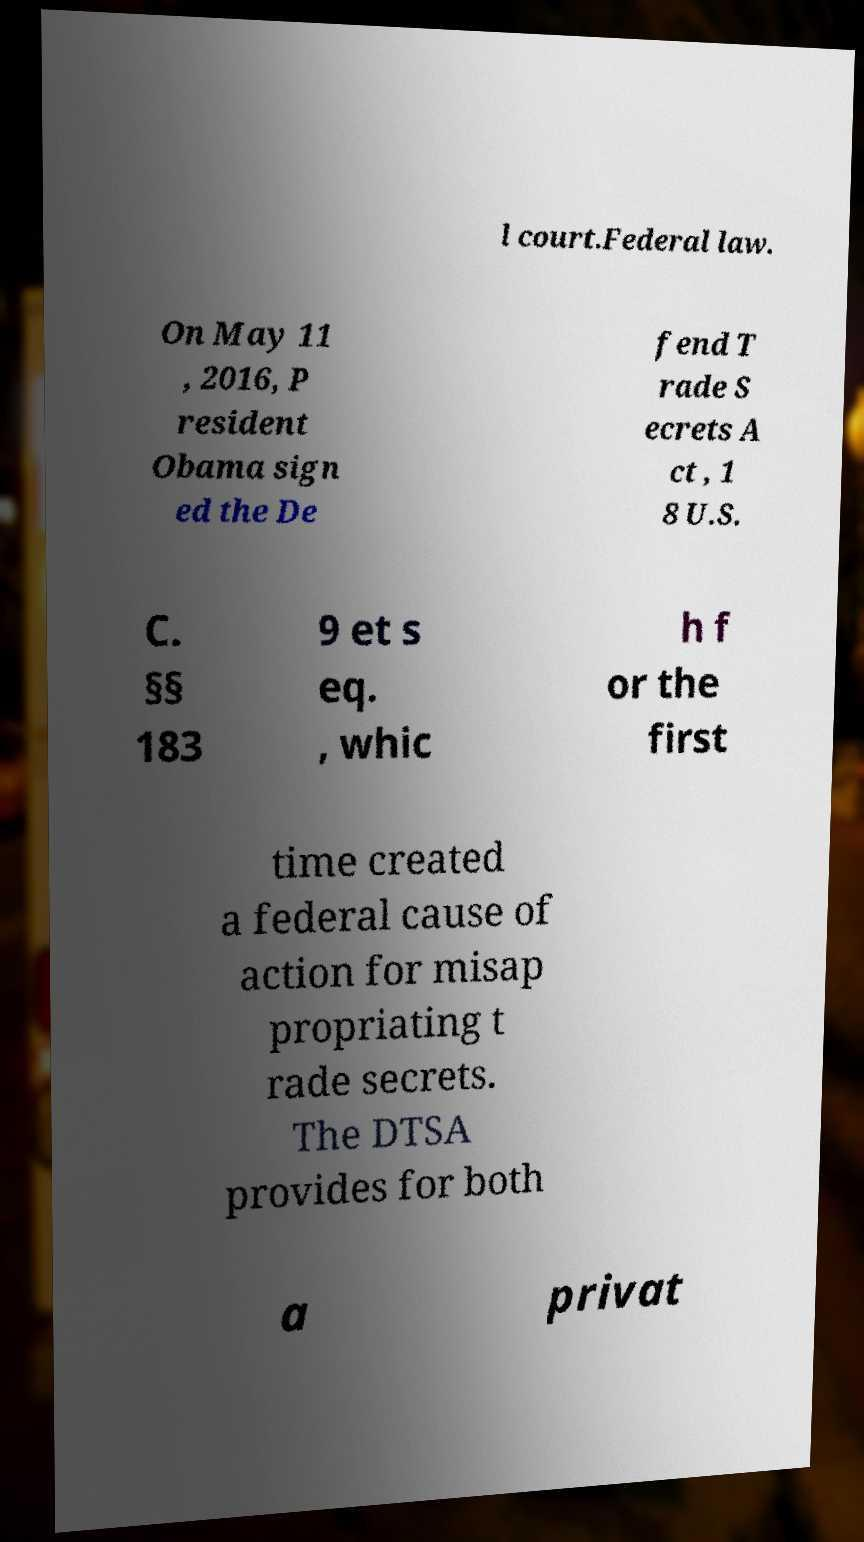Could you assist in decoding the text presented in this image and type it out clearly? l court.Federal law. On May 11 , 2016, P resident Obama sign ed the De fend T rade S ecrets A ct , 1 8 U.S. C. §§ 183 9 et s eq. , whic h f or the first time created a federal cause of action for misap propriating t rade secrets. The DTSA provides for both a privat 